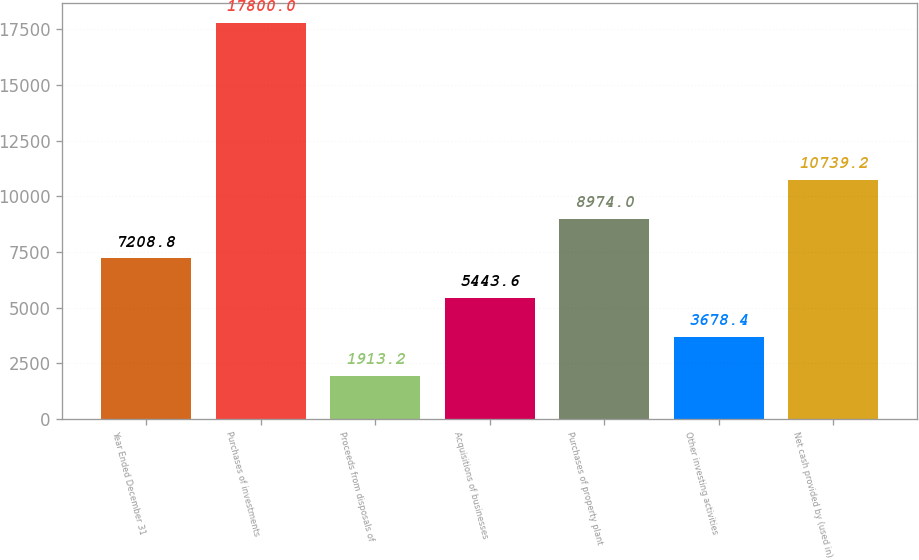Convert chart to OTSL. <chart><loc_0><loc_0><loc_500><loc_500><bar_chart><fcel>Year Ended December 31<fcel>Purchases of investments<fcel>Proceeds from disposals of<fcel>Acquisitions of businesses<fcel>Purchases of property plant<fcel>Other investing activities<fcel>Net cash provided by (used in)<nl><fcel>7208.8<fcel>17800<fcel>1913.2<fcel>5443.6<fcel>8974<fcel>3678.4<fcel>10739.2<nl></chart> 